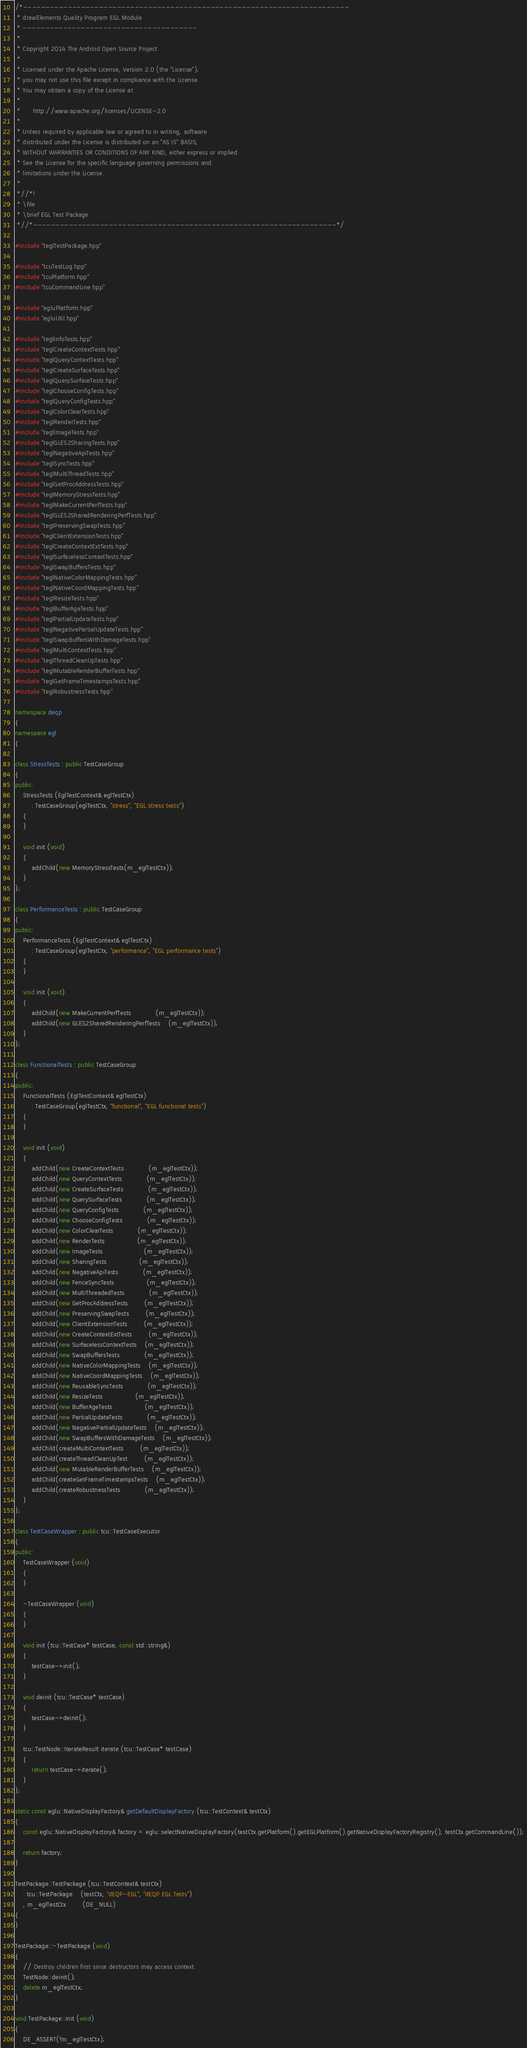<code> <loc_0><loc_0><loc_500><loc_500><_C++_>/*-------------------------------------------------------------------------
 * drawElements Quality Program EGL Module
 * ---------------------------------------
 *
 * Copyright 2014 The Android Open Source Project
 *
 * Licensed under the Apache License, Version 2.0 (the "License");
 * you may not use this file except in compliance with the License.
 * You may obtain a copy of the License at
 *
 *      http://www.apache.org/licenses/LICENSE-2.0
 *
 * Unless required by applicable law or agreed to in writing, software
 * distributed under the License is distributed on an "AS IS" BASIS,
 * WITHOUT WARRANTIES OR CONDITIONS OF ANY KIND, either express or implied.
 * See the License for the specific language governing permissions and
 * limitations under the License.
 *
 *//*!
 * \file
 * \brief EGL Test Package
 *//*--------------------------------------------------------------------*/

#include "teglTestPackage.hpp"

#include "tcuTestLog.hpp"
#include "tcuPlatform.hpp"
#include "tcuCommandLine.hpp"

#include "egluPlatform.hpp"
#include "egluUtil.hpp"

#include "teglInfoTests.hpp"
#include "teglCreateContextTests.hpp"
#include "teglQueryContextTests.hpp"
#include "teglCreateSurfaceTests.hpp"
#include "teglQuerySurfaceTests.hpp"
#include "teglChooseConfigTests.hpp"
#include "teglQueryConfigTests.hpp"
#include "teglColorClearTests.hpp"
#include "teglRenderTests.hpp"
#include "teglImageTests.hpp"
#include "teglGLES2SharingTests.hpp"
#include "teglNegativeApiTests.hpp"
#include "teglSyncTests.hpp"
#include "teglMultiThreadTests.hpp"
#include "teglGetProcAddressTests.hpp"
#include "teglMemoryStressTests.hpp"
#include "teglMakeCurrentPerfTests.hpp"
#include "teglGLES2SharedRenderingPerfTests.hpp"
#include "teglPreservingSwapTests.hpp"
#include "teglClientExtensionTests.hpp"
#include "teglCreateContextExtTests.hpp"
#include "teglSurfacelessContextTests.hpp"
#include "teglSwapBuffersTests.hpp"
#include "teglNativeColorMappingTests.hpp"
#include "teglNativeCoordMappingTests.hpp"
#include "teglResizeTests.hpp"
#include "teglBufferAgeTests.hpp"
#include "teglPartialUpdateTests.hpp"
#include "teglNegativePartialUpdateTests.hpp"
#include "teglSwapBuffersWithDamageTests.hpp"
#include "teglMultiContextTests.hpp"
#include "teglThreadCleanUpTests.hpp"
#include "teglMutableRenderBufferTests.hpp"
#include "teglGetFrameTimestampsTests.hpp"
#include "teglRobustnessTests.hpp"

namespace deqp
{
namespace egl
{

class StressTests : public TestCaseGroup
{
public:
	StressTests (EglTestContext& eglTestCtx)
		: TestCaseGroup(eglTestCtx, "stress", "EGL stress tests")
	{
	}

	void init (void)
	{
		addChild(new MemoryStressTests(m_eglTestCtx));
	}
};

class PerformanceTests : public TestCaseGroup
{
public:
	PerformanceTests (EglTestContext& eglTestCtx)
		: TestCaseGroup(eglTestCtx, "performance", "EGL performance tests")
	{
	}

	void init (void)
	{
		addChild(new MakeCurrentPerfTests			(m_eglTestCtx));
		addChild(new GLES2SharedRenderingPerfTests	(m_eglTestCtx));
	}
};

class FunctionalTests : public TestCaseGroup
{
public:
	FunctionalTests (EglTestContext& eglTestCtx)
		: TestCaseGroup(eglTestCtx, "functional", "EGL functional tests")
	{
	}

	void init (void)
	{
		addChild(new CreateContextTests			(m_eglTestCtx));
		addChild(new QueryContextTests			(m_eglTestCtx));
		addChild(new CreateSurfaceTests			(m_eglTestCtx));
		addChild(new QuerySurfaceTests			(m_eglTestCtx));
		addChild(new QueryConfigTests			(m_eglTestCtx));
		addChild(new ChooseConfigTests			(m_eglTestCtx));
		addChild(new ColorClearTests			(m_eglTestCtx));
		addChild(new RenderTests				(m_eglTestCtx));
		addChild(new ImageTests					(m_eglTestCtx));
		addChild(new SharingTests				(m_eglTestCtx));
		addChild(new NegativeApiTests			(m_eglTestCtx));
		addChild(new FenceSyncTests				(m_eglTestCtx));
		addChild(new MultiThreadedTests			(m_eglTestCtx));
		addChild(new GetProcAddressTests		(m_eglTestCtx));
		addChild(new PreservingSwapTests		(m_eglTestCtx));
		addChild(new ClientExtensionTests		(m_eglTestCtx));
		addChild(new CreateContextExtTests		(m_eglTestCtx));
		addChild(new SurfacelessContextTests	(m_eglTestCtx));
		addChild(new SwapBuffersTests			(m_eglTestCtx));
		addChild(new NativeColorMappingTests	(m_eglTestCtx));
		addChild(new NativeCoordMappingTests	(m_eglTestCtx));
		addChild(new ReusableSyncTests			(m_eglTestCtx));
		addChild(new ResizeTests				(m_eglTestCtx));
		addChild(new BufferAgeTests				(m_eglTestCtx));
		addChild(new PartialUpdateTests			(m_eglTestCtx));
		addChild(new NegativePartialUpdateTests	(m_eglTestCtx));
		addChild(new SwapBuffersWithDamageTests	(m_eglTestCtx));
		addChild(createMultiContextTests		(m_eglTestCtx));
		addChild(createThreadCleanUpTest		(m_eglTestCtx));
		addChild(new MutableRenderBufferTests	(m_eglTestCtx));
		addChild(createGetFrameTimestampsTests	(m_eglTestCtx));
		addChild(createRobustnessTests			(m_eglTestCtx));
	}
};

class TestCaseWrapper : public tcu::TestCaseExecutor
{
public:
	TestCaseWrapper (void)
	{
	}

	~TestCaseWrapper (void)
	{
	}

	void init (tcu::TestCase* testCase, const std::string&)
	{
		testCase->init();
	}

	void deinit (tcu::TestCase* testCase)
	{
		testCase->deinit();
	}

	tcu::TestNode::IterateResult iterate (tcu::TestCase* testCase)
	{
		return testCase->iterate();
	}
};

static const eglu::NativeDisplayFactory& getDefaultDisplayFactory (tcu::TestContext& testCtx)
{
	const eglu::NativeDisplayFactory& factory = eglu::selectNativeDisplayFactory(testCtx.getPlatform().getEGLPlatform().getNativeDisplayFactoryRegistry(), testCtx.getCommandLine());

	return factory;
}

TestPackage::TestPackage (tcu::TestContext& testCtx)
	: tcu::TestPackage	(testCtx, "dEQP-EGL", "dEQP EGL Tests")
	, m_eglTestCtx		(DE_NULL)
{
}

TestPackage::~TestPackage (void)
{
	// Destroy children first since destructors may access context.
	TestNode::deinit();
	delete m_eglTestCtx;
}

void TestPackage::init (void)
{
	DE_ASSERT(!m_eglTestCtx);</code> 